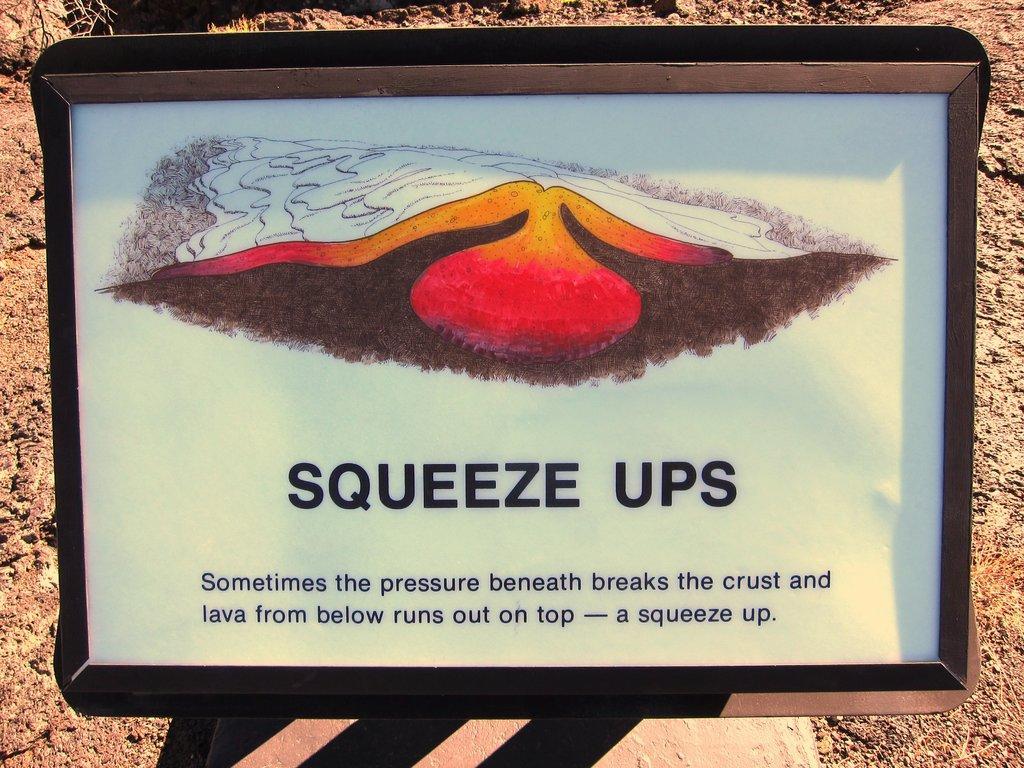Can you describe this image briefly? In this picture there is a poster which is placed on this black steel box. Behind that I can see the stones and dry leaves. In that poster I can see the painting which shown about the lava. 